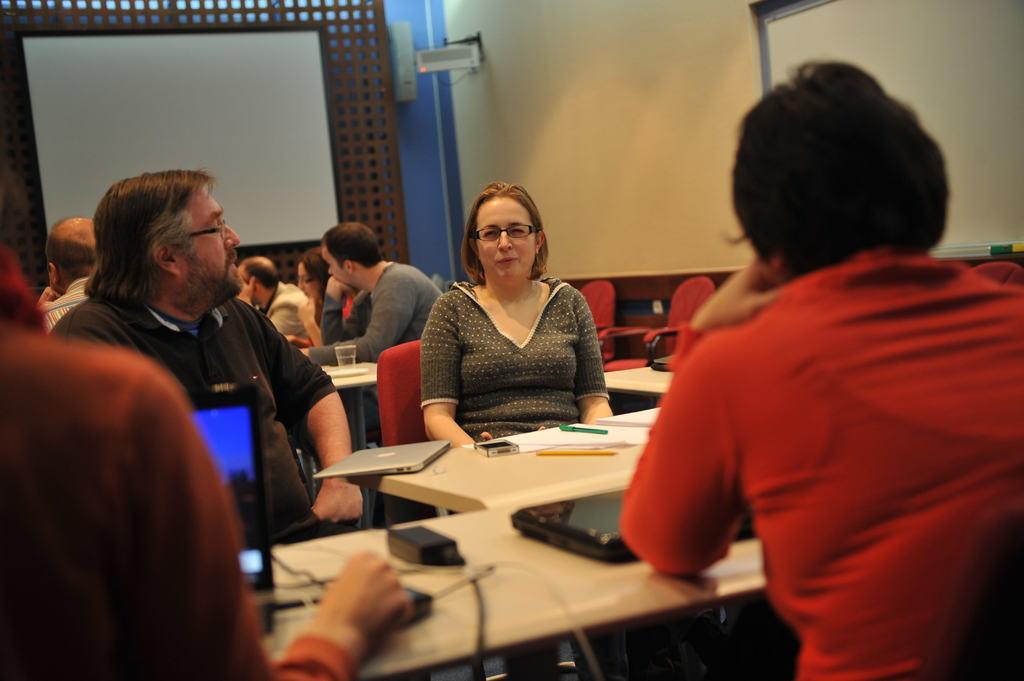Describe this image in one or two sentences. This picture shows few people seated on the chairs and a person operating laptop and we see few books,laptop on the table and we see a projector screen back of them 